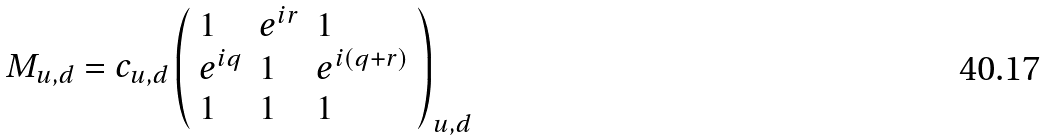Convert formula to latex. <formula><loc_0><loc_0><loc_500><loc_500>M _ { u , d } = c _ { u , d } \left ( \begin{array} { l l l } 1 & e ^ { i r } & 1 \\ e ^ { i q } & 1 & e ^ { i ( q + r ) } \\ 1 & 1 & 1 \end{array} \right ) _ { u , d }</formula> 